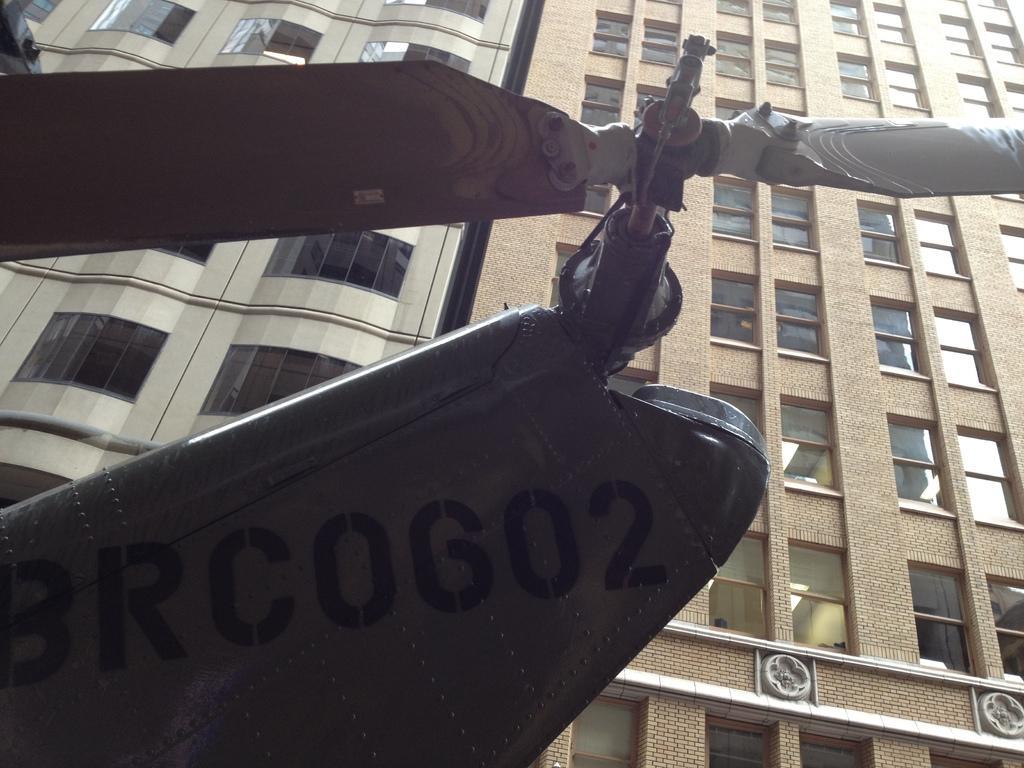Could you give a brief overview of what you see in this image? On the left side, there is an object having a fan. In the background, there are buildings which are having windows. 